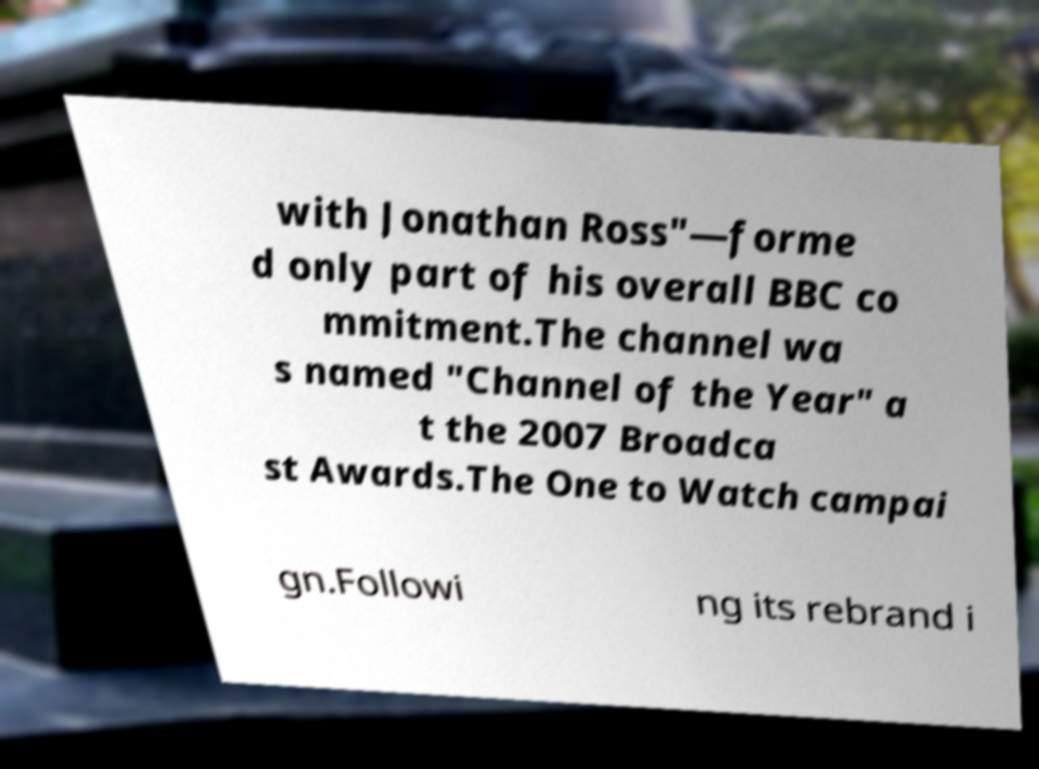There's text embedded in this image that I need extracted. Can you transcribe it verbatim? with Jonathan Ross"—forme d only part of his overall BBC co mmitment.The channel wa s named "Channel of the Year" a t the 2007 Broadca st Awards.The One to Watch campai gn.Followi ng its rebrand i 